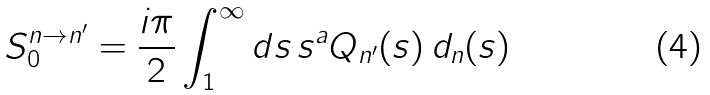<formula> <loc_0><loc_0><loc_500><loc_500>S _ { 0 } ^ { n \to n ^ { \prime } } = \frac { i \pi } { 2 } \int _ { 1 } ^ { \infty } d s \, s ^ { a } Q _ { n ^ { \prime } } ( s ) \, d _ { n } ( s )</formula> 